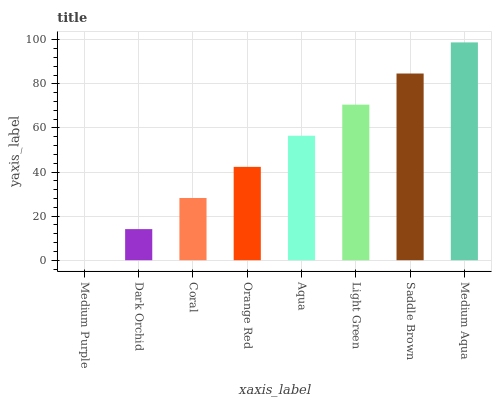Is Medium Purple the minimum?
Answer yes or no. Yes. Is Medium Aqua the maximum?
Answer yes or no. Yes. Is Dark Orchid the minimum?
Answer yes or no. No. Is Dark Orchid the maximum?
Answer yes or no. No. Is Dark Orchid greater than Medium Purple?
Answer yes or no. Yes. Is Medium Purple less than Dark Orchid?
Answer yes or no. Yes. Is Medium Purple greater than Dark Orchid?
Answer yes or no. No. Is Dark Orchid less than Medium Purple?
Answer yes or no. No. Is Aqua the high median?
Answer yes or no. Yes. Is Orange Red the low median?
Answer yes or no. Yes. Is Light Green the high median?
Answer yes or no. No. Is Dark Orchid the low median?
Answer yes or no. No. 